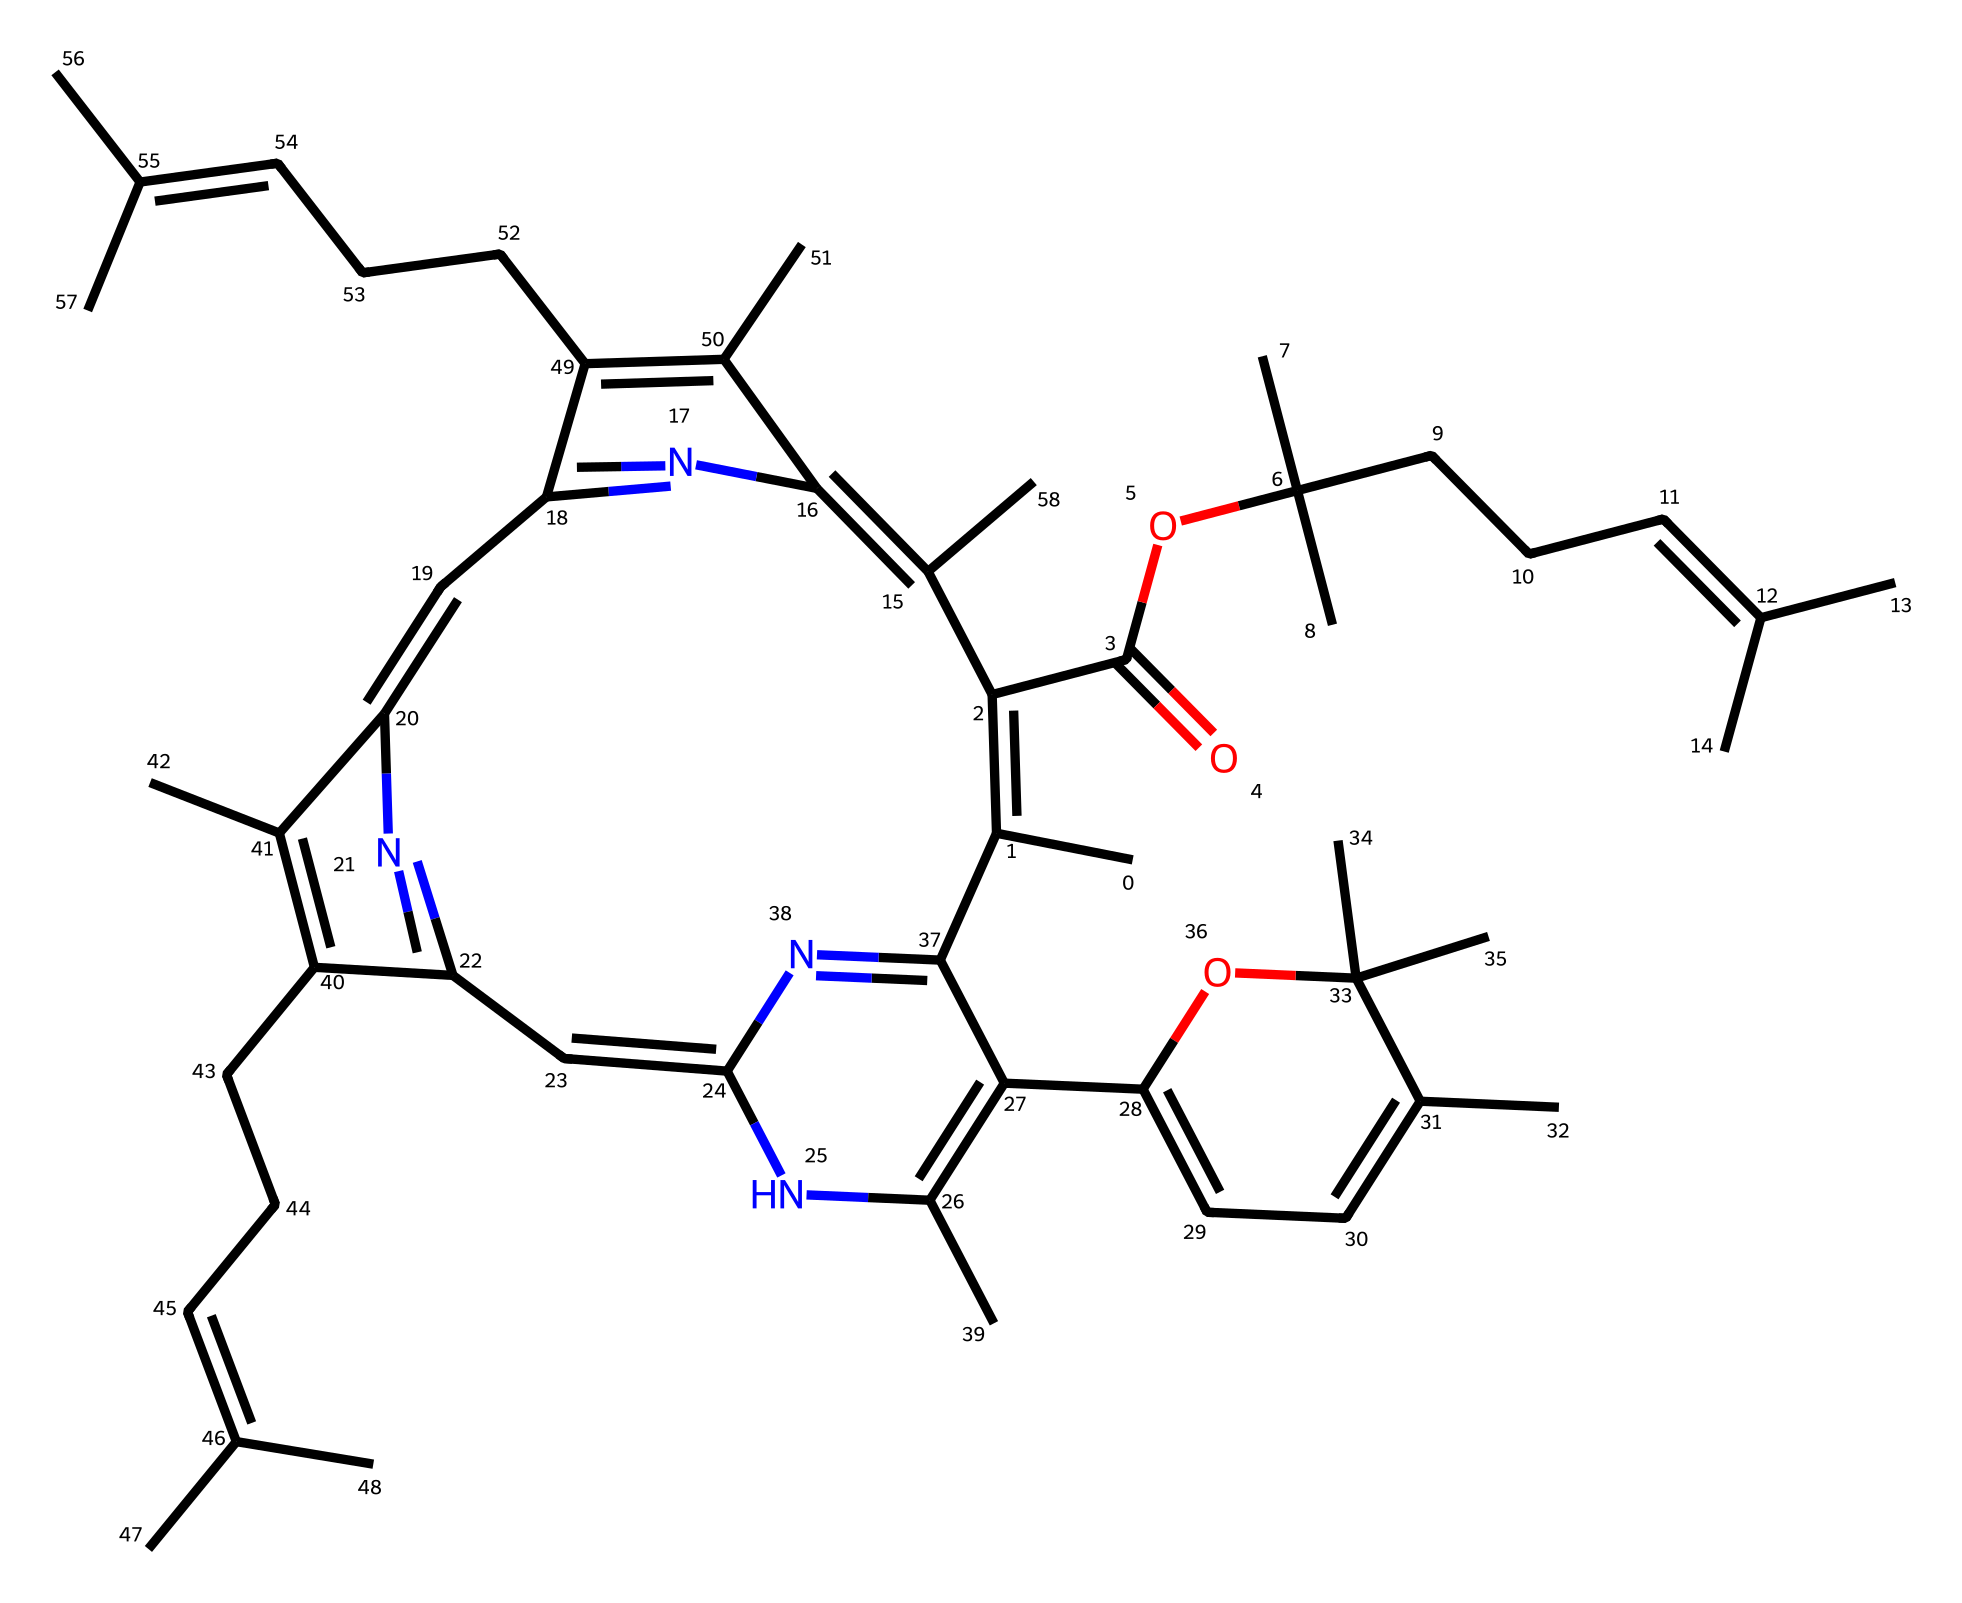what is the primary function of chlorophyll in plants? Chlorophyll is responsible for photosynthesis, allowing plants to convert light energy into chemical energy.
Answer: photosynthesis how many carbon atoms are present in this chlorophyll structure? By analyzing the SMILES representation, we can count the carbon atoms, which are prominently featured. There are 28 carbon atoms present in total.
Answer: 28 what type of functional group is present in chlorophyll? The structure of chlorophyll contains an ester functional group (O=C-O), which is identified in the part of the molecule next to the alkyl chain.
Answer: ester what is the total number of nitrogen atoms in this chlorophyll structure? Counting the nitrogen atoms in the structure yields a total of 4, as they are explicitly represented in the SMILES notation.
Answer: 4 which part of the chlorophyll structure is responsible for its green color? The long conjugated system with alternating double bonds (aromatic rings) allows for absorption of light in specific wavelengths, which contributes to the green color.
Answer: conjugated system how does the presence of nitrogen atoms influence the properties of chlorophyll? The nitrogen atoms contribute to the coordination with magnesium in the chlorophyll structure, which is critical for its ability to absorb light during photosynthesis.
Answer: coordination with magnesium 